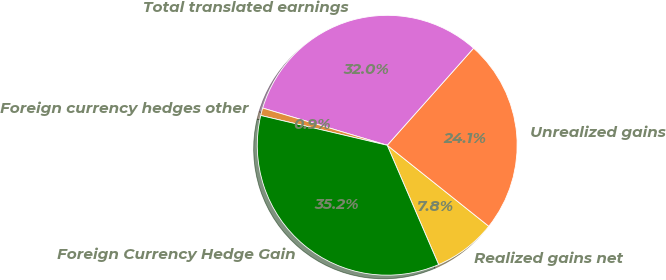<chart> <loc_0><loc_0><loc_500><loc_500><pie_chart><fcel>Realized gains net<fcel>Unrealized gains<fcel>Total translated earnings<fcel>Foreign currency hedges other<fcel>Foreign Currency Hedge Gain<nl><fcel>7.81%<fcel>24.14%<fcel>31.95%<fcel>0.94%<fcel>35.15%<nl></chart> 